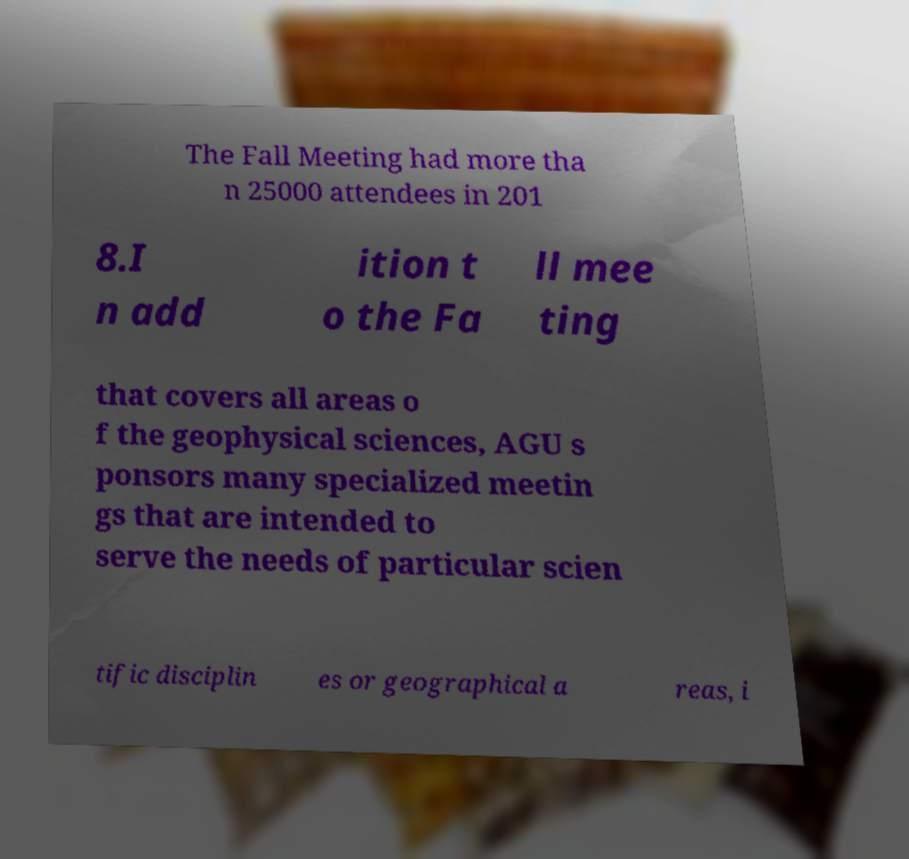I need the written content from this picture converted into text. Can you do that? The Fall Meeting had more tha n 25000 attendees in 201 8.I n add ition t o the Fa ll mee ting that covers all areas o f the geophysical sciences, AGU s ponsors many specialized meetin gs that are intended to serve the needs of particular scien tific disciplin es or geographical a reas, i 